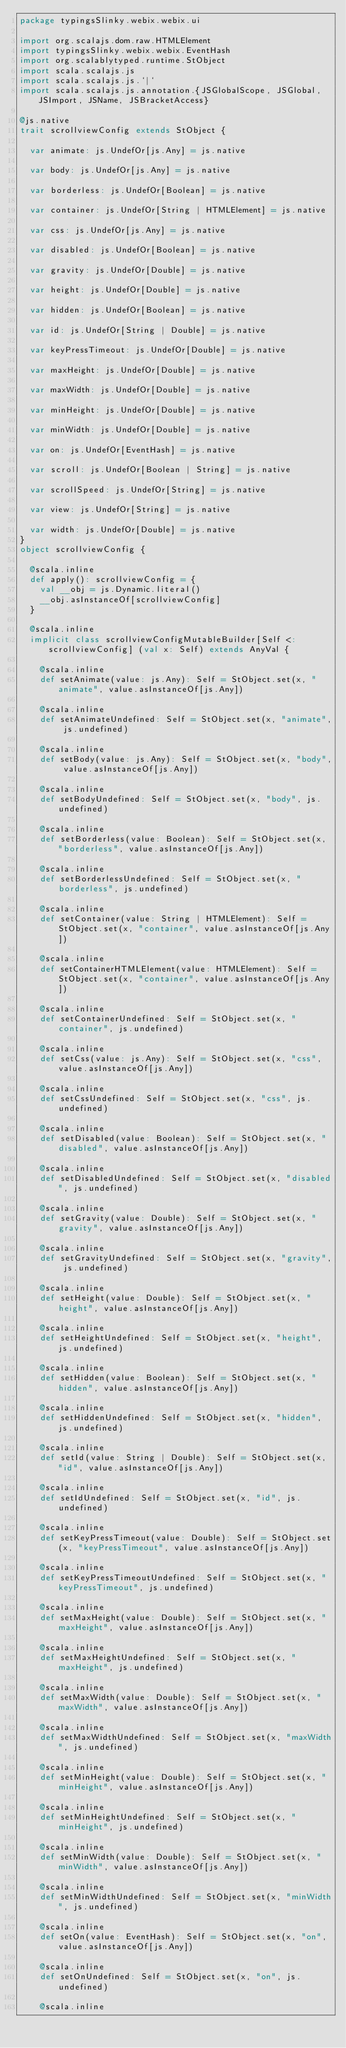Convert code to text. <code><loc_0><loc_0><loc_500><loc_500><_Scala_>package typingsSlinky.webix.webix.ui

import org.scalajs.dom.raw.HTMLElement
import typingsSlinky.webix.webix.EventHash
import org.scalablytyped.runtime.StObject
import scala.scalajs.js
import scala.scalajs.js.`|`
import scala.scalajs.js.annotation.{JSGlobalScope, JSGlobal, JSImport, JSName, JSBracketAccess}

@js.native
trait scrollviewConfig extends StObject {
  
  var animate: js.UndefOr[js.Any] = js.native
  
  var body: js.UndefOr[js.Any] = js.native
  
  var borderless: js.UndefOr[Boolean] = js.native
  
  var container: js.UndefOr[String | HTMLElement] = js.native
  
  var css: js.UndefOr[js.Any] = js.native
  
  var disabled: js.UndefOr[Boolean] = js.native
  
  var gravity: js.UndefOr[Double] = js.native
  
  var height: js.UndefOr[Double] = js.native
  
  var hidden: js.UndefOr[Boolean] = js.native
  
  var id: js.UndefOr[String | Double] = js.native
  
  var keyPressTimeout: js.UndefOr[Double] = js.native
  
  var maxHeight: js.UndefOr[Double] = js.native
  
  var maxWidth: js.UndefOr[Double] = js.native
  
  var minHeight: js.UndefOr[Double] = js.native
  
  var minWidth: js.UndefOr[Double] = js.native
  
  var on: js.UndefOr[EventHash] = js.native
  
  var scroll: js.UndefOr[Boolean | String] = js.native
  
  var scrollSpeed: js.UndefOr[String] = js.native
  
  var view: js.UndefOr[String] = js.native
  
  var width: js.UndefOr[Double] = js.native
}
object scrollviewConfig {
  
  @scala.inline
  def apply(): scrollviewConfig = {
    val __obj = js.Dynamic.literal()
    __obj.asInstanceOf[scrollviewConfig]
  }
  
  @scala.inline
  implicit class scrollviewConfigMutableBuilder[Self <: scrollviewConfig] (val x: Self) extends AnyVal {
    
    @scala.inline
    def setAnimate(value: js.Any): Self = StObject.set(x, "animate", value.asInstanceOf[js.Any])
    
    @scala.inline
    def setAnimateUndefined: Self = StObject.set(x, "animate", js.undefined)
    
    @scala.inline
    def setBody(value: js.Any): Self = StObject.set(x, "body", value.asInstanceOf[js.Any])
    
    @scala.inline
    def setBodyUndefined: Self = StObject.set(x, "body", js.undefined)
    
    @scala.inline
    def setBorderless(value: Boolean): Self = StObject.set(x, "borderless", value.asInstanceOf[js.Any])
    
    @scala.inline
    def setBorderlessUndefined: Self = StObject.set(x, "borderless", js.undefined)
    
    @scala.inline
    def setContainer(value: String | HTMLElement): Self = StObject.set(x, "container", value.asInstanceOf[js.Any])
    
    @scala.inline
    def setContainerHTMLElement(value: HTMLElement): Self = StObject.set(x, "container", value.asInstanceOf[js.Any])
    
    @scala.inline
    def setContainerUndefined: Self = StObject.set(x, "container", js.undefined)
    
    @scala.inline
    def setCss(value: js.Any): Self = StObject.set(x, "css", value.asInstanceOf[js.Any])
    
    @scala.inline
    def setCssUndefined: Self = StObject.set(x, "css", js.undefined)
    
    @scala.inline
    def setDisabled(value: Boolean): Self = StObject.set(x, "disabled", value.asInstanceOf[js.Any])
    
    @scala.inline
    def setDisabledUndefined: Self = StObject.set(x, "disabled", js.undefined)
    
    @scala.inline
    def setGravity(value: Double): Self = StObject.set(x, "gravity", value.asInstanceOf[js.Any])
    
    @scala.inline
    def setGravityUndefined: Self = StObject.set(x, "gravity", js.undefined)
    
    @scala.inline
    def setHeight(value: Double): Self = StObject.set(x, "height", value.asInstanceOf[js.Any])
    
    @scala.inline
    def setHeightUndefined: Self = StObject.set(x, "height", js.undefined)
    
    @scala.inline
    def setHidden(value: Boolean): Self = StObject.set(x, "hidden", value.asInstanceOf[js.Any])
    
    @scala.inline
    def setHiddenUndefined: Self = StObject.set(x, "hidden", js.undefined)
    
    @scala.inline
    def setId(value: String | Double): Self = StObject.set(x, "id", value.asInstanceOf[js.Any])
    
    @scala.inline
    def setIdUndefined: Self = StObject.set(x, "id", js.undefined)
    
    @scala.inline
    def setKeyPressTimeout(value: Double): Self = StObject.set(x, "keyPressTimeout", value.asInstanceOf[js.Any])
    
    @scala.inline
    def setKeyPressTimeoutUndefined: Self = StObject.set(x, "keyPressTimeout", js.undefined)
    
    @scala.inline
    def setMaxHeight(value: Double): Self = StObject.set(x, "maxHeight", value.asInstanceOf[js.Any])
    
    @scala.inline
    def setMaxHeightUndefined: Self = StObject.set(x, "maxHeight", js.undefined)
    
    @scala.inline
    def setMaxWidth(value: Double): Self = StObject.set(x, "maxWidth", value.asInstanceOf[js.Any])
    
    @scala.inline
    def setMaxWidthUndefined: Self = StObject.set(x, "maxWidth", js.undefined)
    
    @scala.inline
    def setMinHeight(value: Double): Self = StObject.set(x, "minHeight", value.asInstanceOf[js.Any])
    
    @scala.inline
    def setMinHeightUndefined: Self = StObject.set(x, "minHeight", js.undefined)
    
    @scala.inline
    def setMinWidth(value: Double): Self = StObject.set(x, "minWidth", value.asInstanceOf[js.Any])
    
    @scala.inline
    def setMinWidthUndefined: Self = StObject.set(x, "minWidth", js.undefined)
    
    @scala.inline
    def setOn(value: EventHash): Self = StObject.set(x, "on", value.asInstanceOf[js.Any])
    
    @scala.inline
    def setOnUndefined: Self = StObject.set(x, "on", js.undefined)
    
    @scala.inline</code> 